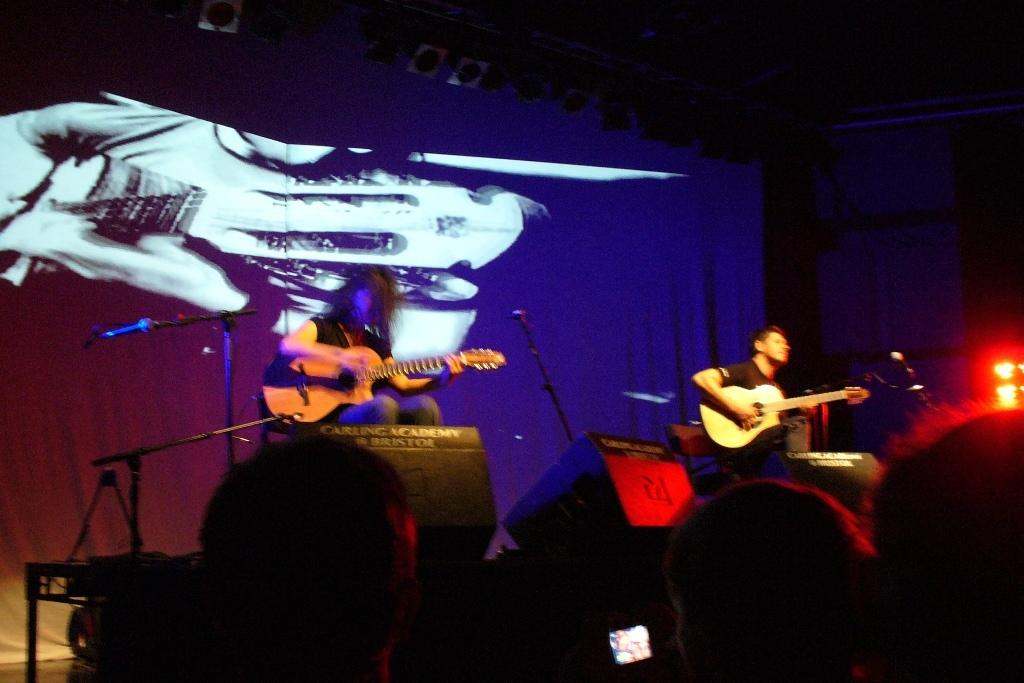How many men are in the image? There are two men in the image. What are the men doing in the image? The men are seated and playing guitar. Where are the men located in the image? The men are on a dais. What is the audience doing in the image? The audience is watching the men play guitar. Can you see any goose wandering around on the farm in the image? There is no farm or goose present in the image. Is there a birthday cake visible in the image? There is no birthday cake present in the image. 